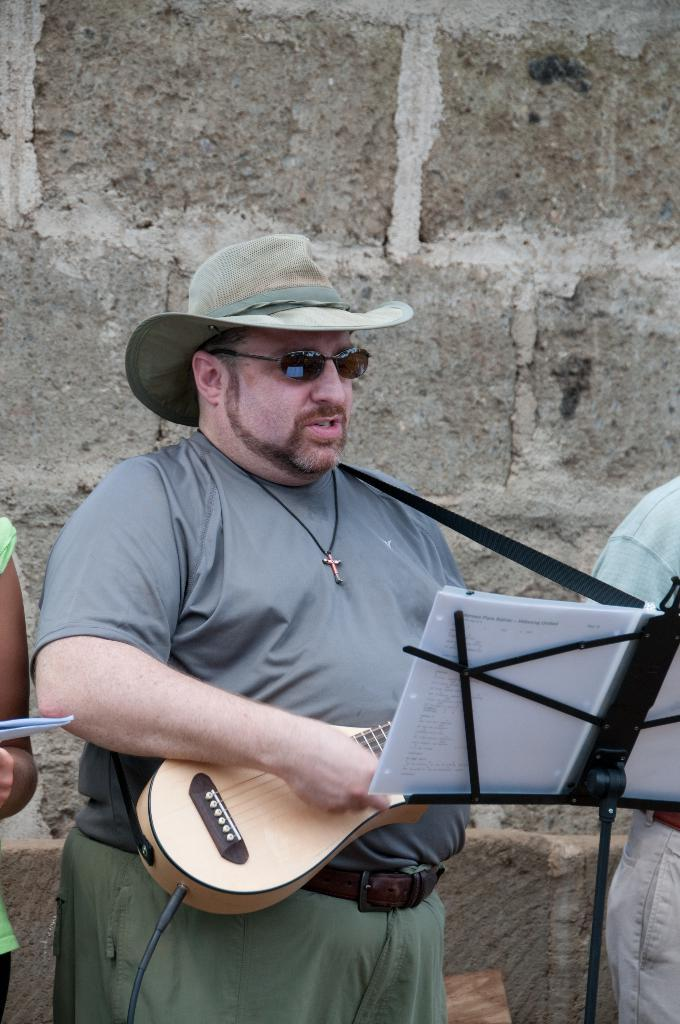Who is present in the image? There is a man in the image. What is the man wearing on his head? The man is wearing a hat. What accessory is the man wearing on his face? The man is wearing spectacles. What object is the man holding in the image? The man is holding a guitar. What is placed in front of the man? There is a paper in front of the man. What type of trouble is the man causing at the airport in the image? There is no airport present in the image, and the man is not causing any trouble. 